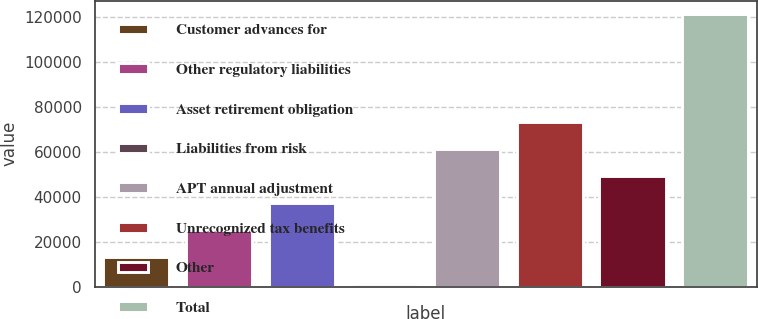Convert chart. <chart><loc_0><loc_0><loc_500><loc_500><bar_chart><fcel>Customer advances for<fcel>Other regulatory liabilities<fcel>Asset retirement obligation<fcel>Liabilities from risk<fcel>APT annual adjustment<fcel>Unrecognized tax benefits<fcel>Other<fcel>Total<nl><fcel>13237.4<fcel>25225.8<fcel>37214.2<fcel>1249<fcel>61191<fcel>73179.4<fcel>49202.6<fcel>121133<nl></chart> 